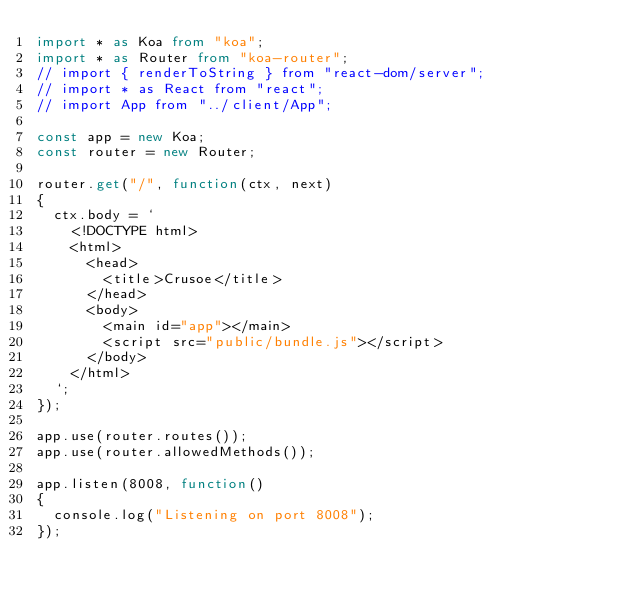<code> <loc_0><loc_0><loc_500><loc_500><_TypeScript_>import * as Koa from "koa";
import * as Router from "koa-router";
// import { renderToString } from "react-dom/server";
// import * as React from "react";
// import App from "../client/App";

const app = new Koa;
const router = new Router;

router.get("/", function(ctx, next)
{
  ctx.body = `
    <!DOCTYPE html>
    <html>
      <head>
        <title>Crusoe</title>
      </head>
      <body>
        <main id="app"></main>
        <script src="public/bundle.js"></script>
      </body>
    </html>
  `;
});

app.use(router.routes());
app.use(router.allowedMethods());

app.listen(8008, function()
{
  console.log("Listening on port 8008");
});

</code> 